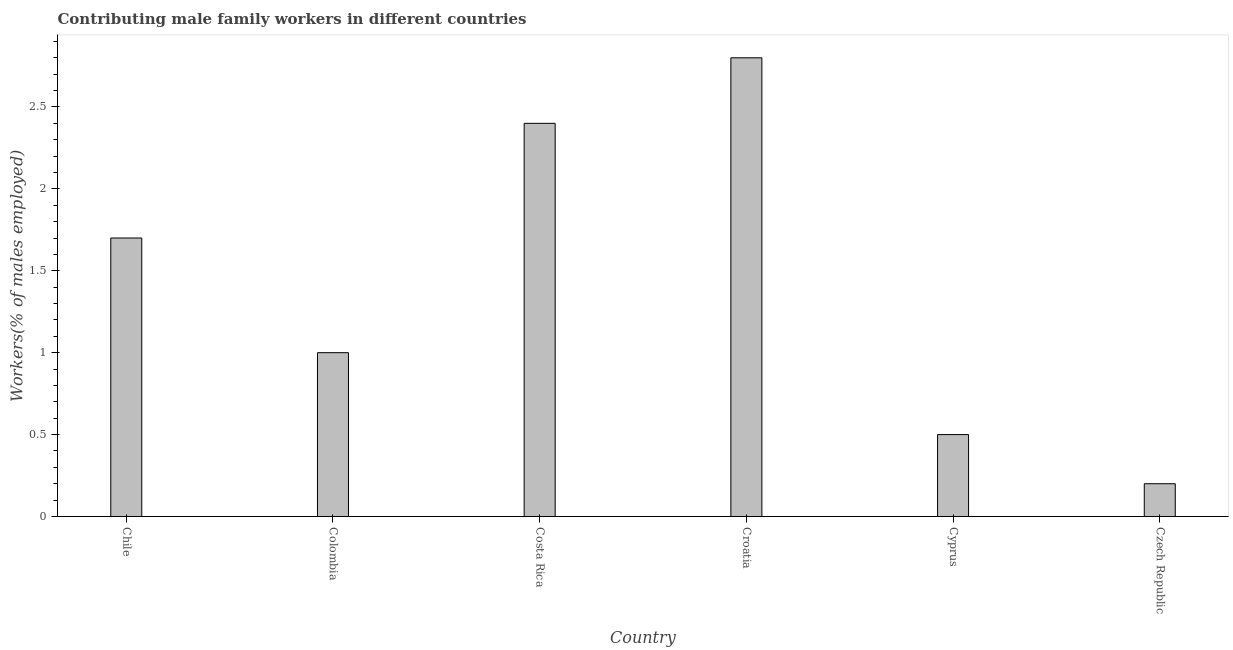Does the graph contain any zero values?
Give a very brief answer. No. Does the graph contain grids?
Offer a very short reply. No. What is the title of the graph?
Your response must be concise. Contributing male family workers in different countries. What is the label or title of the X-axis?
Provide a short and direct response. Country. What is the label or title of the Y-axis?
Your answer should be compact. Workers(% of males employed). What is the contributing male family workers in Czech Republic?
Ensure brevity in your answer.  0.2. Across all countries, what is the maximum contributing male family workers?
Offer a terse response. 2.8. Across all countries, what is the minimum contributing male family workers?
Offer a very short reply. 0.2. In which country was the contributing male family workers maximum?
Your response must be concise. Croatia. In which country was the contributing male family workers minimum?
Provide a succinct answer. Czech Republic. What is the sum of the contributing male family workers?
Make the answer very short. 8.6. What is the average contributing male family workers per country?
Offer a very short reply. 1.43. What is the median contributing male family workers?
Ensure brevity in your answer.  1.35. In how many countries, is the contributing male family workers greater than 2.8 %?
Provide a short and direct response. 0. What is the ratio of the contributing male family workers in Chile to that in Croatia?
Your answer should be compact. 0.61. Is the difference between the contributing male family workers in Chile and Cyprus greater than the difference between any two countries?
Provide a succinct answer. No. Are all the bars in the graph horizontal?
Offer a terse response. No. What is the difference between two consecutive major ticks on the Y-axis?
Your answer should be very brief. 0.5. Are the values on the major ticks of Y-axis written in scientific E-notation?
Keep it short and to the point. No. What is the Workers(% of males employed) of Chile?
Ensure brevity in your answer.  1.7. What is the Workers(% of males employed) in Colombia?
Provide a succinct answer. 1. What is the Workers(% of males employed) of Costa Rica?
Make the answer very short. 2.4. What is the Workers(% of males employed) of Croatia?
Offer a very short reply. 2.8. What is the Workers(% of males employed) in Cyprus?
Your answer should be compact. 0.5. What is the Workers(% of males employed) in Czech Republic?
Offer a terse response. 0.2. What is the difference between the Workers(% of males employed) in Chile and Costa Rica?
Offer a very short reply. -0.7. What is the difference between the Workers(% of males employed) in Colombia and Croatia?
Your response must be concise. -1.8. What is the difference between the Workers(% of males employed) in Colombia and Czech Republic?
Your answer should be very brief. 0.8. What is the difference between the Workers(% of males employed) in Costa Rica and Croatia?
Provide a succinct answer. -0.4. What is the difference between the Workers(% of males employed) in Costa Rica and Cyprus?
Keep it short and to the point. 1.9. What is the difference between the Workers(% of males employed) in Costa Rica and Czech Republic?
Offer a very short reply. 2.2. What is the difference between the Workers(% of males employed) in Croatia and Czech Republic?
Give a very brief answer. 2.6. What is the difference between the Workers(% of males employed) in Cyprus and Czech Republic?
Provide a succinct answer. 0.3. What is the ratio of the Workers(% of males employed) in Chile to that in Costa Rica?
Your answer should be very brief. 0.71. What is the ratio of the Workers(% of males employed) in Chile to that in Croatia?
Your answer should be compact. 0.61. What is the ratio of the Workers(% of males employed) in Colombia to that in Costa Rica?
Provide a short and direct response. 0.42. What is the ratio of the Workers(% of males employed) in Colombia to that in Croatia?
Provide a short and direct response. 0.36. What is the ratio of the Workers(% of males employed) in Colombia to that in Czech Republic?
Your answer should be compact. 5. What is the ratio of the Workers(% of males employed) in Costa Rica to that in Croatia?
Your response must be concise. 0.86. What is the ratio of the Workers(% of males employed) in Costa Rica to that in Cyprus?
Give a very brief answer. 4.8. What is the ratio of the Workers(% of males employed) in Cyprus to that in Czech Republic?
Offer a terse response. 2.5. 